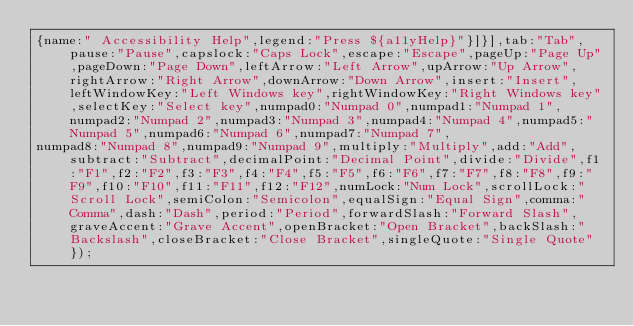<code> <loc_0><loc_0><loc_500><loc_500><_JavaScript_>{name:" Accessibility Help",legend:"Press ${a11yHelp}"}]}],tab:"Tab",pause:"Pause",capslock:"Caps Lock",escape:"Escape",pageUp:"Page Up",pageDown:"Page Down",leftArrow:"Left Arrow",upArrow:"Up Arrow",rightArrow:"Right Arrow",downArrow:"Down Arrow",insert:"Insert",leftWindowKey:"Left Windows key",rightWindowKey:"Right Windows key",selectKey:"Select key",numpad0:"Numpad 0",numpad1:"Numpad 1",numpad2:"Numpad 2",numpad3:"Numpad 3",numpad4:"Numpad 4",numpad5:"Numpad 5",numpad6:"Numpad 6",numpad7:"Numpad 7",
numpad8:"Numpad 8",numpad9:"Numpad 9",multiply:"Multiply",add:"Add",subtract:"Subtract",decimalPoint:"Decimal Point",divide:"Divide",f1:"F1",f2:"F2",f3:"F3",f4:"F4",f5:"F5",f6:"F6",f7:"F7",f8:"F8",f9:"F9",f10:"F10",f11:"F11",f12:"F12",numLock:"Num Lock",scrollLock:"Scroll Lock",semiColon:"Semicolon",equalSign:"Equal Sign",comma:"Comma",dash:"Dash",period:"Period",forwardSlash:"Forward Slash",graveAccent:"Grave Accent",openBracket:"Open Bracket",backSlash:"Backslash",closeBracket:"Close Bracket",singleQuote:"Single Quote"});</code> 